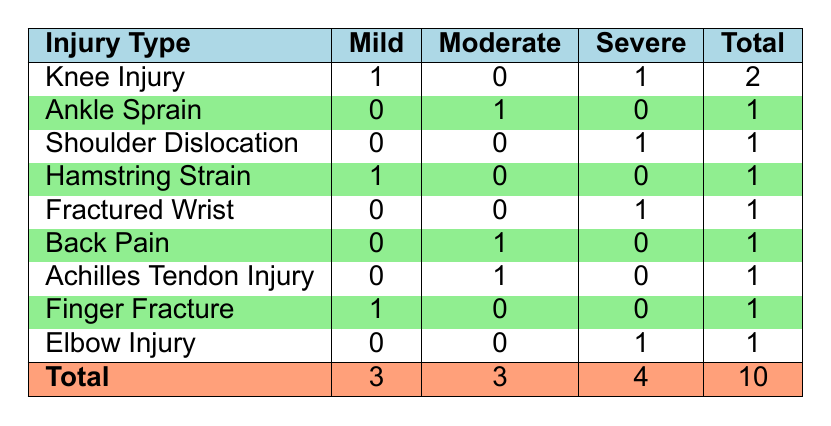What is the total number of mild injuries reported? There are three mild injuries listed in the table: Knee Injury (1), Hamstring Strain (1), and Finger Fracture (1). Summing these gives a total of 3 mild injuries.
Answer: 3 Which injury type has the highest severity of injuries? The highest severity is represented by the counts in the Severe column. Fractured Wrist, Shoulder Dislocation, Knee Injury, and Elbow Injury each have one severe case, while Knee Injury has a total of 2 (1 Mild and 1 Severe) and is the only type represented more than once. Therefore, multiple types have the highest severe count.
Answer: Multiple types (Knee Injury, Fractured Wrist, Shoulder Dislocation, Elbow Injury) Is there a type of injury with only mild severity? Looking at the Mild column, both Hamstring Strain and Finger Fracture have injuries with mild severity. There are no injury types that have only mild injuries reported without other severities.
Answer: No How many total severe injuries are reported for all types combined? To find the total severe injuries, we look at the Severe column and count: 1 (Shoulder Dislocation) + 1 (Fractured Wrist) + 1 (Knee Injury) + 1 (Elbow Injury) = 4. So, there are 4 severe injuries in total.
Answer: 4 What is the proportion of moderate injuries compared to total injuries? There are 3 moderate injuries reported (Ankle Sprain, Back Pain, and Achilles Tendon Injury) out of a total of 10 injuries. Thus, the proportion is 3 out of 10, which simplifies to 0.3 or 30%.
Answer: 30% Which injury type has no moderate injuries listed? The table shows that Knee Injury, Fractured Wrist, and Finger Fracture have no moderate injuries listed. This means they do not appear in the Moderate column at all.
Answer: Knee Injury, Fractured Wrist, Finger Fracture How many athletes reported knee injuries? From the table, there is one Mild (Knee Injury by Jasper van Dijk) and one Severe (Knee Injury by Milan de Vries). Therefore, there are 2 athletes reporting knee injuries.
Answer: 2 Which severity level has the least number of reported injuries? Reviewing the totals in each severity column: Mild has 3, Moderate has 3, and Severe has 4. Since Mild and Moderate both have the least amount at 3, we conclude they are tied for the least reported injuries.
Answer: Mild and Moderate are tied as the least 